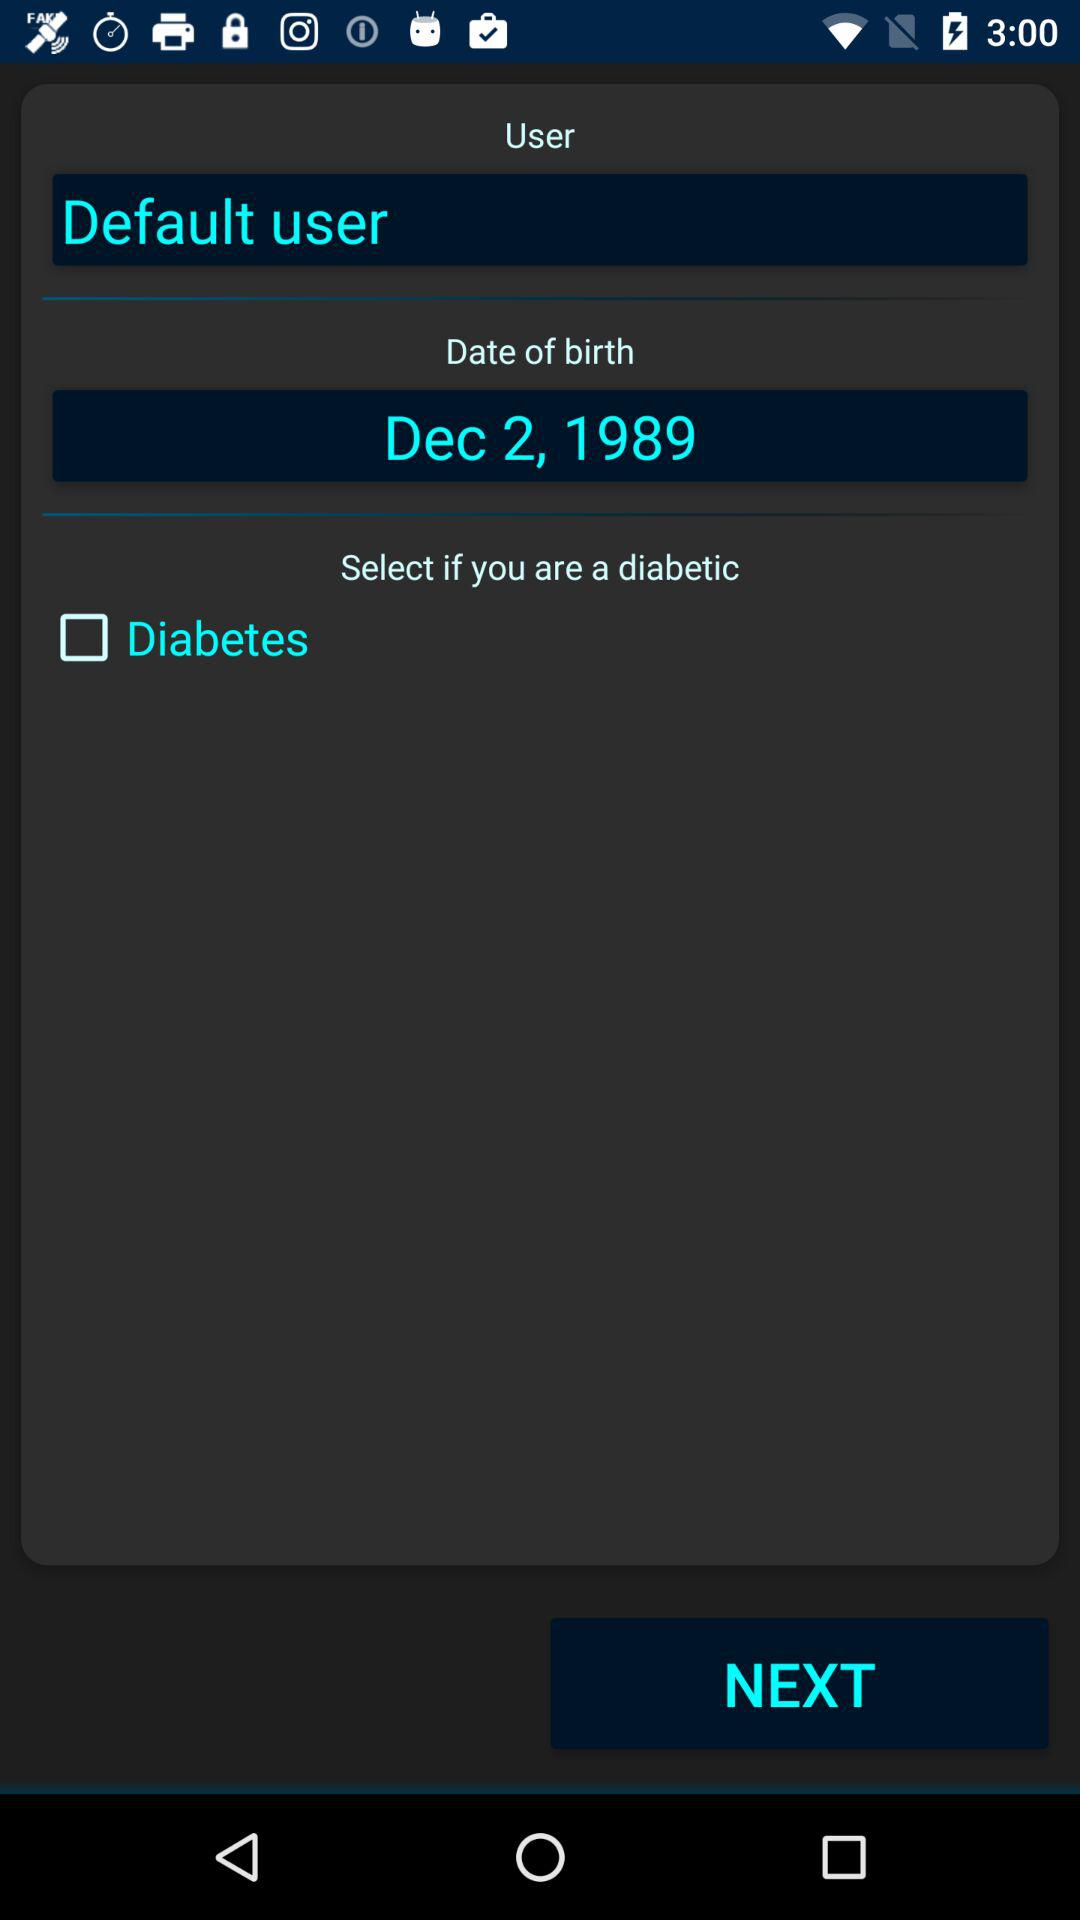What is the status of "Diabetes"? The status is "off". 